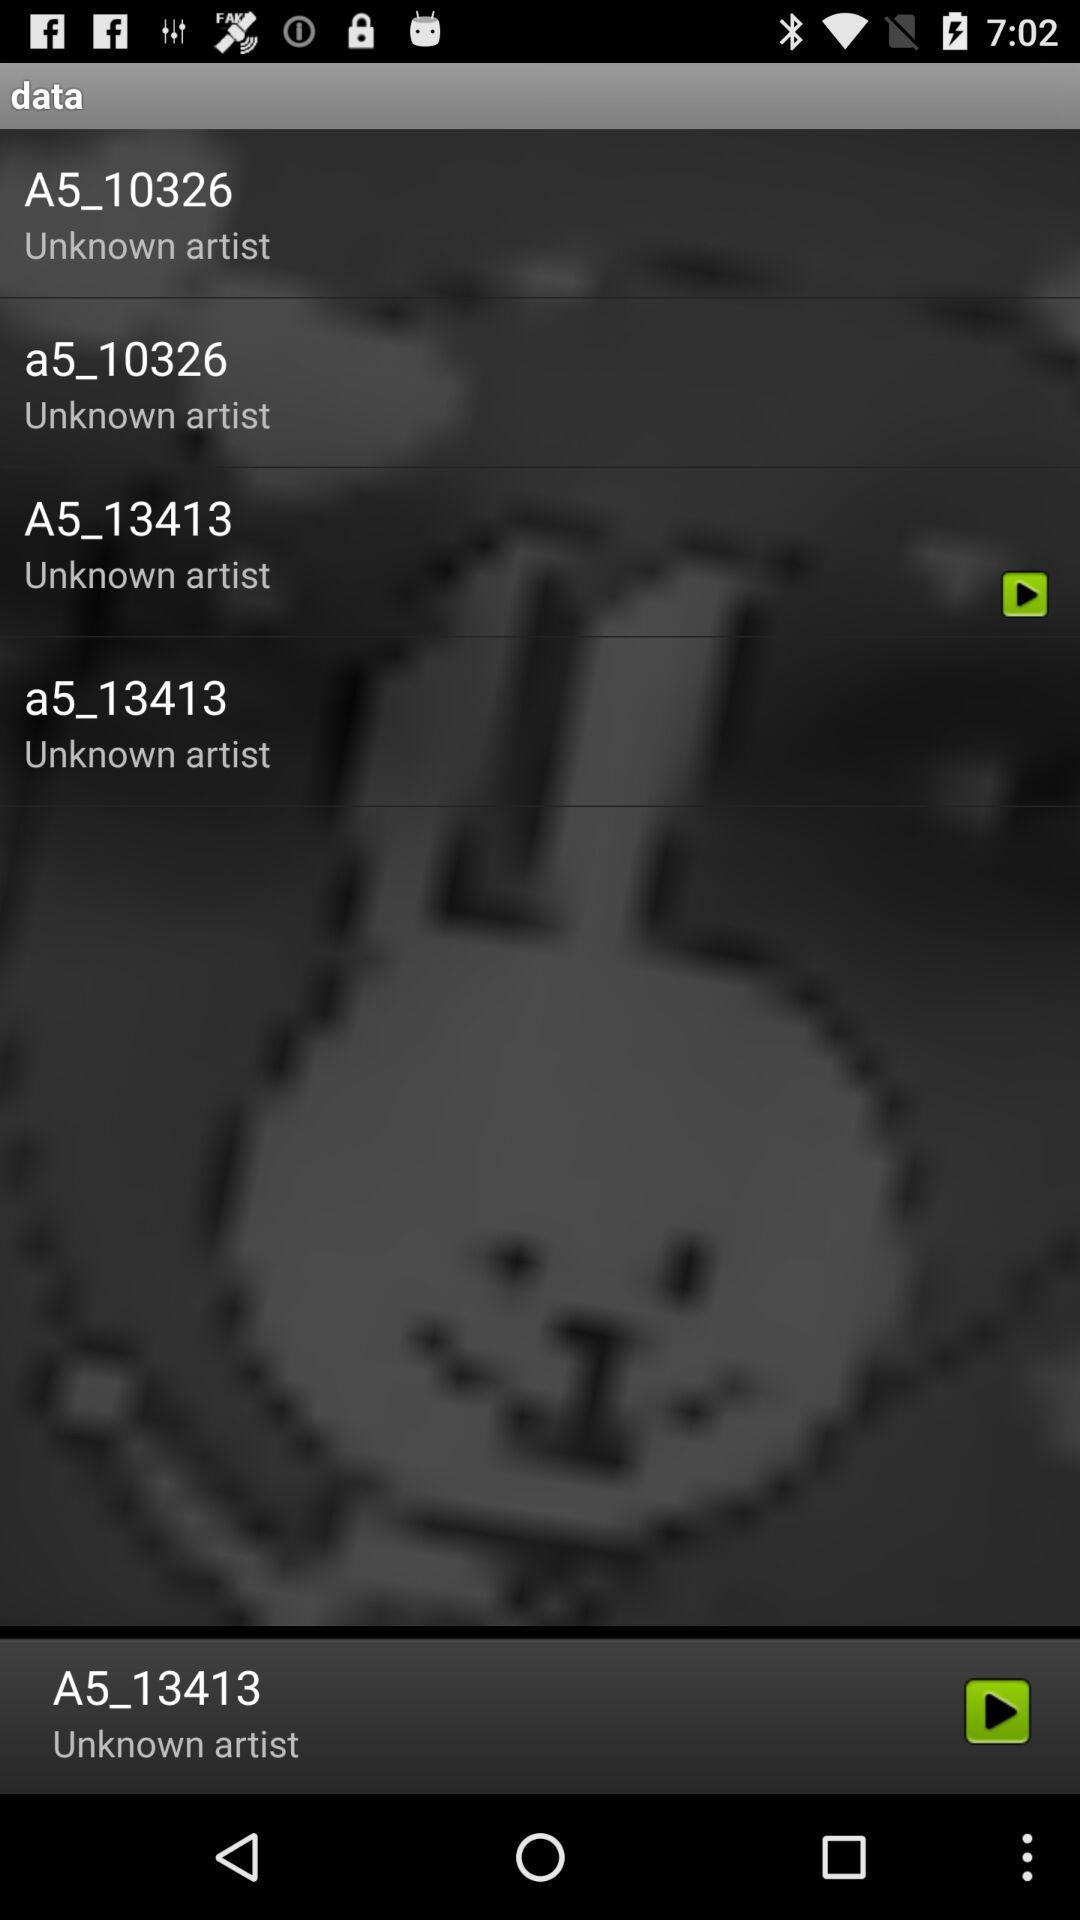Which track was last played? The last played track was "A5_13413". 